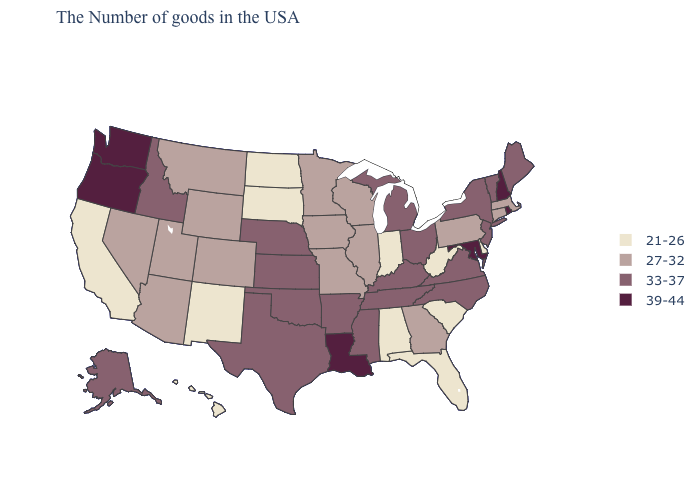What is the highest value in the West ?
Give a very brief answer. 39-44. What is the lowest value in the West?
Concise answer only. 21-26. Among the states that border Idaho , which have the lowest value?
Answer briefly. Wyoming, Utah, Montana, Nevada. Name the states that have a value in the range 39-44?
Write a very short answer. Rhode Island, New Hampshire, Maryland, Louisiana, Washington, Oregon. What is the value of Nevada?
Be succinct. 27-32. What is the lowest value in states that border Washington?
Be succinct. 33-37. How many symbols are there in the legend?
Write a very short answer. 4. How many symbols are there in the legend?
Short answer required. 4. Which states have the lowest value in the Northeast?
Keep it brief. Massachusetts, Connecticut, Pennsylvania. Among the states that border Montana , which have the lowest value?
Be succinct. South Dakota, North Dakota. What is the value of New Jersey?
Give a very brief answer. 33-37. Does the first symbol in the legend represent the smallest category?
Quick response, please. Yes. What is the value of Delaware?
Answer briefly. 21-26. Name the states that have a value in the range 27-32?
Concise answer only. Massachusetts, Connecticut, Pennsylvania, Georgia, Wisconsin, Illinois, Missouri, Minnesota, Iowa, Wyoming, Colorado, Utah, Montana, Arizona, Nevada. Does Delaware have the lowest value in the South?
Write a very short answer. Yes. 